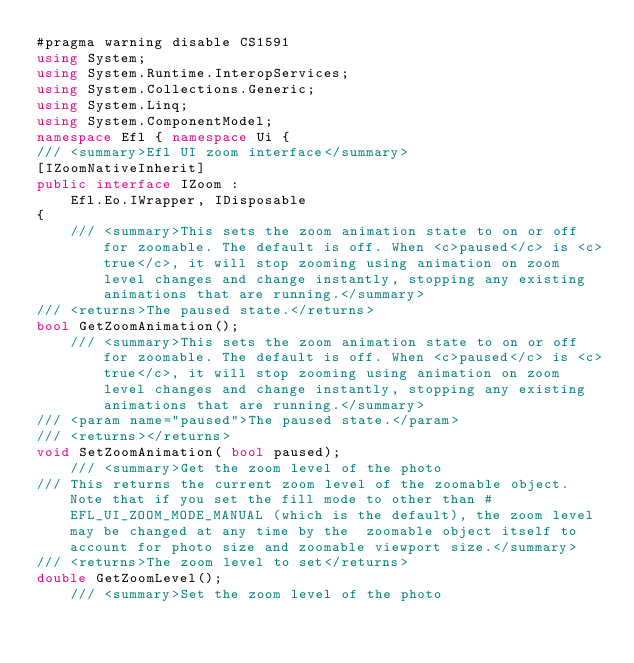<code> <loc_0><loc_0><loc_500><loc_500><_C#_>#pragma warning disable CS1591
using System;
using System.Runtime.InteropServices;
using System.Collections.Generic;
using System.Linq;
using System.ComponentModel;
namespace Efl { namespace Ui { 
/// <summary>Efl UI zoom interface</summary>
[IZoomNativeInherit]
public interface IZoom : 
    Efl.Eo.IWrapper, IDisposable
{
    /// <summary>This sets the zoom animation state to on or off for zoomable. The default is off. When <c>paused</c> is <c>true</c>, it will stop zooming using animation on zoom level changes and change instantly, stopping any existing animations that are running.</summary>
/// <returns>The paused state.</returns>
bool GetZoomAnimation();
    /// <summary>This sets the zoom animation state to on or off for zoomable. The default is off. When <c>paused</c> is <c>true</c>, it will stop zooming using animation on zoom level changes and change instantly, stopping any existing animations that are running.</summary>
/// <param name="paused">The paused state.</param>
/// <returns></returns>
void SetZoomAnimation( bool paused);
    /// <summary>Get the zoom level of the photo
/// This returns the current zoom level of the zoomable object. Note that if you set the fill mode to other than #EFL_UI_ZOOM_MODE_MANUAL (which is the default), the zoom level may be changed at any time by the  zoomable object itself to account for photo size and zoomable viewport size.</summary>
/// <returns>The zoom level to set</returns>
double GetZoomLevel();
    /// <summary>Set the zoom level of the photo</code> 